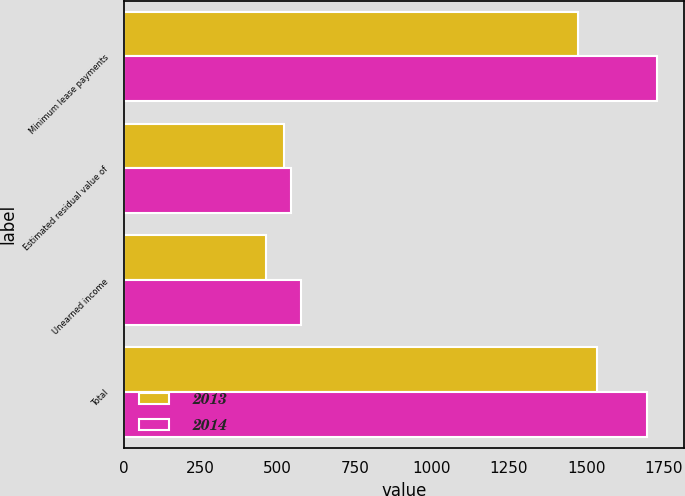Convert chart. <chart><loc_0><loc_0><loc_500><loc_500><stacked_bar_chart><ecel><fcel>Minimum lease payments<fcel>Estimated residual value of<fcel>Unearned income<fcel>Total<nl><fcel>2013<fcel>1475<fcel>521<fcel>461<fcel>1535<nl><fcel>2014<fcel>1731<fcel>543<fcel>575<fcel>1699<nl></chart> 